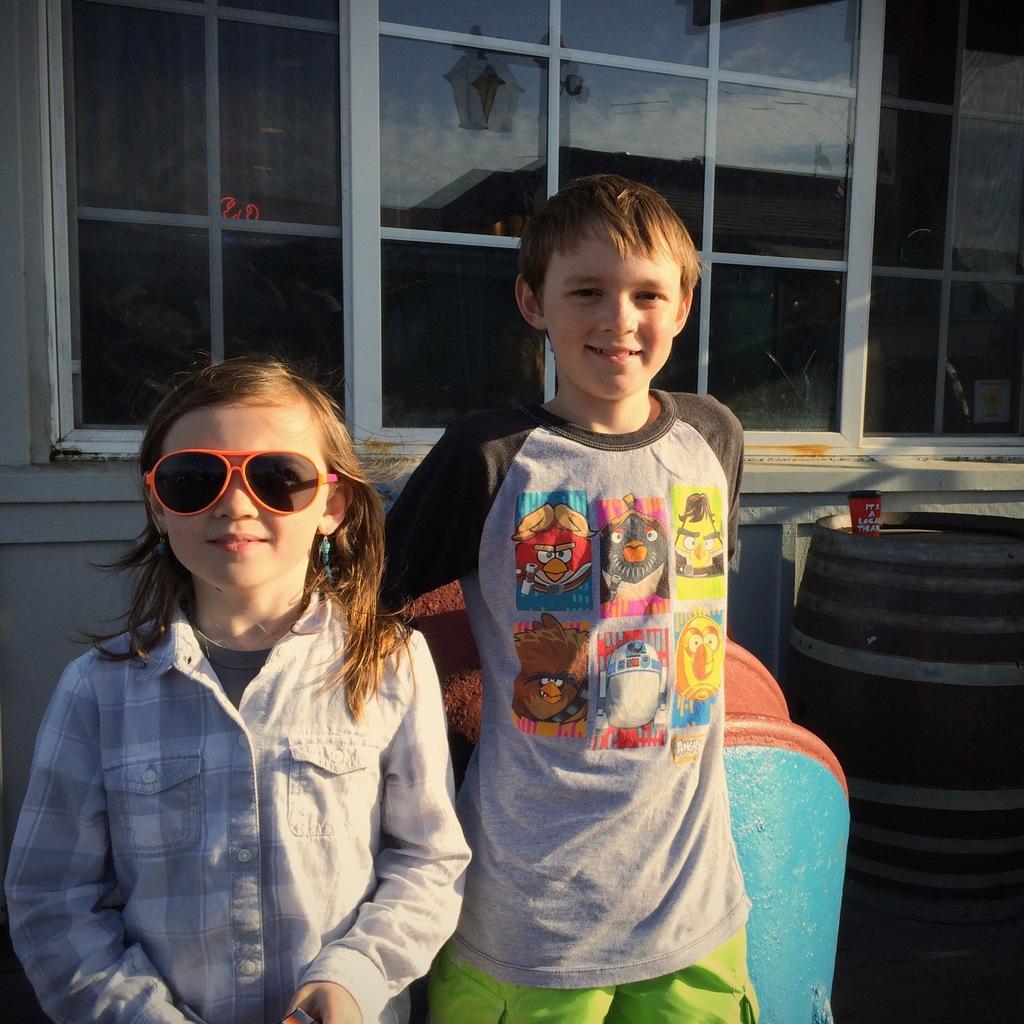How would you summarize this image in a sentence or two? To the left side of the image there is a girl with shirt is standing and also she kept goggles. Beside her there is a boy with cartoon t-shirt is standing. And to the right corner of the image there is a big drum. And in the background there is a wall with glass window. 